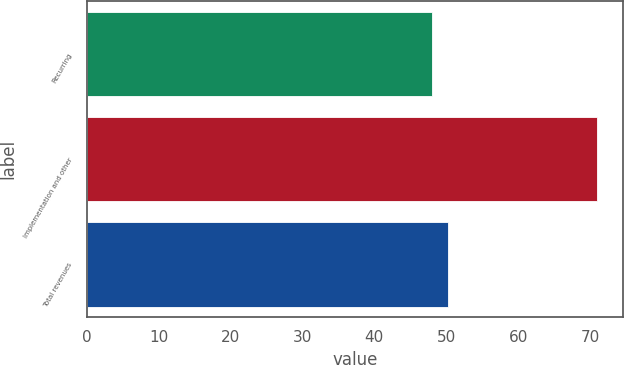<chart> <loc_0><loc_0><loc_500><loc_500><bar_chart><fcel>Recurring<fcel>Implementation and other<fcel>Total revenues<nl><fcel>48<fcel>71<fcel>50.3<nl></chart> 